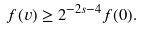Convert formula to latex. <formula><loc_0><loc_0><loc_500><loc_500>f ( v ) \geq 2 ^ { - 2 s - 4 } f ( 0 ) .</formula> 